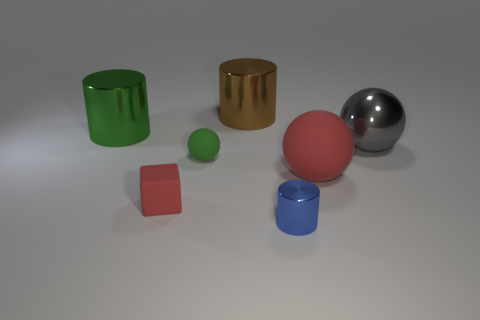What size is the ball that is the same color as the small rubber cube?
Keep it short and to the point. Large. Is the number of big rubber spheres that are left of the large brown metallic thing the same as the number of big rubber spheres that are in front of the blue metal cylinder?
Keep it short and to the point. Yes. There is a green rubber thing; is its size the same as the green object behind the gray sphere?
Offer a very short reply. No. Is the number of spheres that are on the left side of the gray thing greater than the number of blue metallic cylinders?
Your answer should be compact. Yes. What number of blocks are the same size as the green metal object?
Give a very brief answer. 0. There is a thing that is behind the big green thing; is its size the same as the metallic thing to the right of the big rubber object?
Offer a very short reply. Yes. Are there more green cylinders on the right side of the big brown cylinder than big gray shiny balls left of the large gray metallic sphere?
Give a very brief answer. No. How many tiny green objects have the same shape as the blue metal object?
Give a very brief answer. 0. What is the material of the red object that is the same size as the green metal object?
Offer a terse response. Rubber. Is there a big gray thing that has the same material as the tiny blue thing?
Make the answer very short. Yes. 